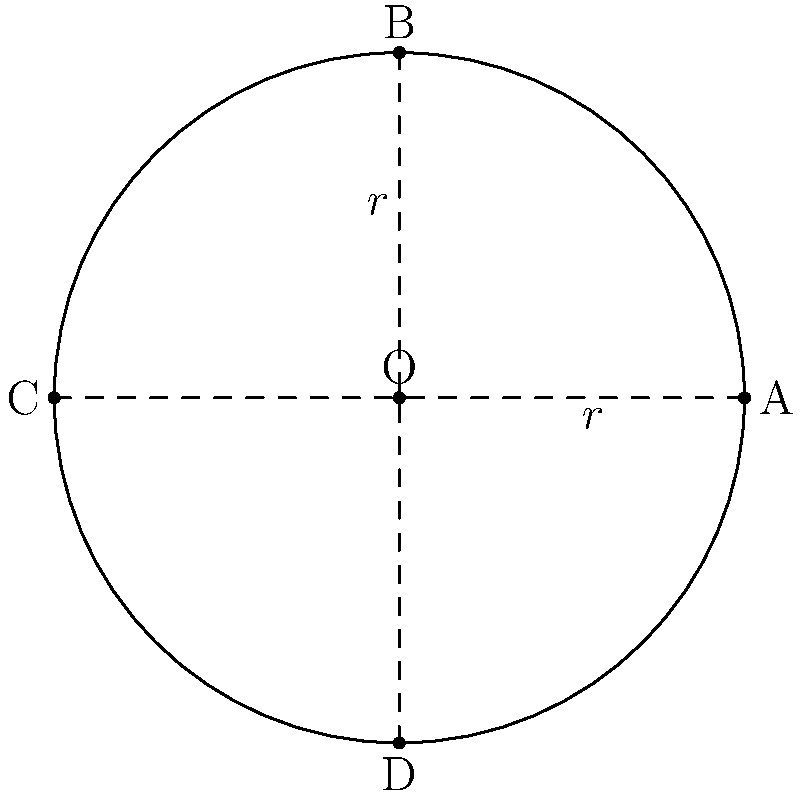As the director planning a Star Wars-themed production, you need to design Princess Leia's iconic hair buns. Assuming each bun can be approximated as an ellipse, and you want to ensure a consistent curvature, how would you express the curvature $\kappa$ at point A on the ellipse in terms of the semi-major axis $a$ and semi-minor axis $b$? To find the curvature of Princess Leia's hair buns, we'll follow these steps:

1) The general equation of an ellipse centered at the origin is:

   $$\frac{x^2}{a^2} + \frac{y^2}{b^2} = 1$$

   where $a$ is the semi-major axis and $b$ is the semi-minor axis.

2) The curvature $\kappa$ of a curve in Cartesian coordinates is given by:

   $$\kappa = \frac{|y''|}{(1 + (y')^2)^{3/2}}$$

3) To find $y'$ and $y''$, we first express $y$ in terms of $x$:

   $$y = \pm b\sqrt{1 - \frac{x^2}{a^2}}$$

4) Differentiating once:

   $$y' = \mp \frac{bx}{a^2\sqrt{1 - \frac{x^2}{a^2}}}$$

5) Differentiating again:

   $$y'' = \mp \frac{b}{a^2}\left(\frac{1}{\sqrt{1 - \frac{x^2}{a^2}}} + \frac{x^2}{a^2(1 - \frac{x^2}{a^2})^{3/2}}\right)$$

6) At point A $(a,0)$, $x = a$ and $y = 0$. Substituting these into the expressions for $y'$ and $y''$:

   $$y'|_{A} = 0$$
   $$y''|_{A} = -\frac{b}{a^2}$$

7) Now, substituting these values into the curvature formula:

   $$\kappa_{A} = \frac{|\frac{b}{a^2}|}{(1 + 0^2)^{3/2}} = \frac{b}{a^2}$$

Thus, the curvature at point A of Princess Leia's hair bun is $\frac{b}{a^2}$.
Answer: $\kappa = \frac{b}{a^2}$ 